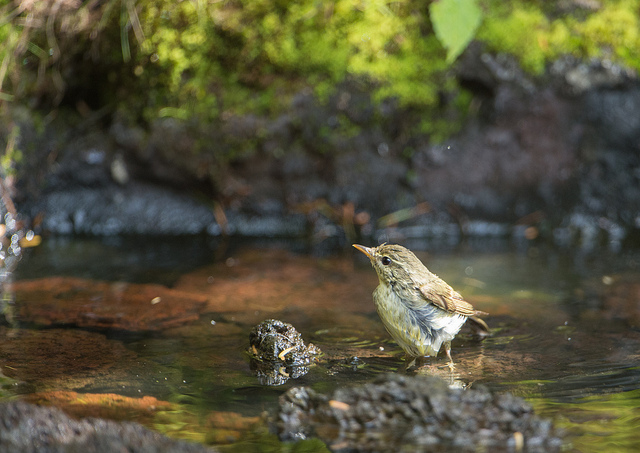<image>What type of bird is this? I am not sure what type of bird this is. It could be a sparrow, thrush, wren, parakeet, or pigeon. What type of bird is this? I am not sure what type of bird is this. It could be a sparrow, thrush, wren, parakeet, gray bird, or pigeon. 